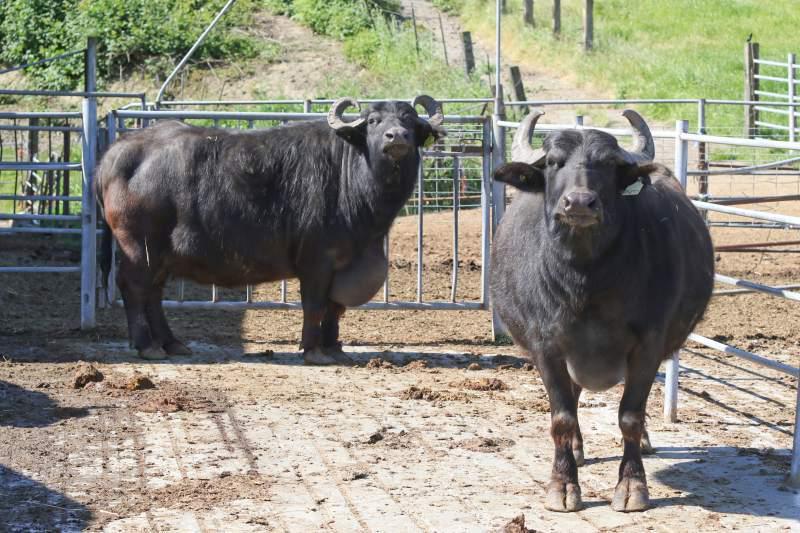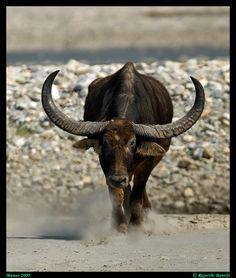The first image is the image on the left, the second image is the image on the right. Considering the images on both sides, is "At least one image shows a non-living water buffalo, with its actual flesh removed." valid? Answer yes or no. No. 